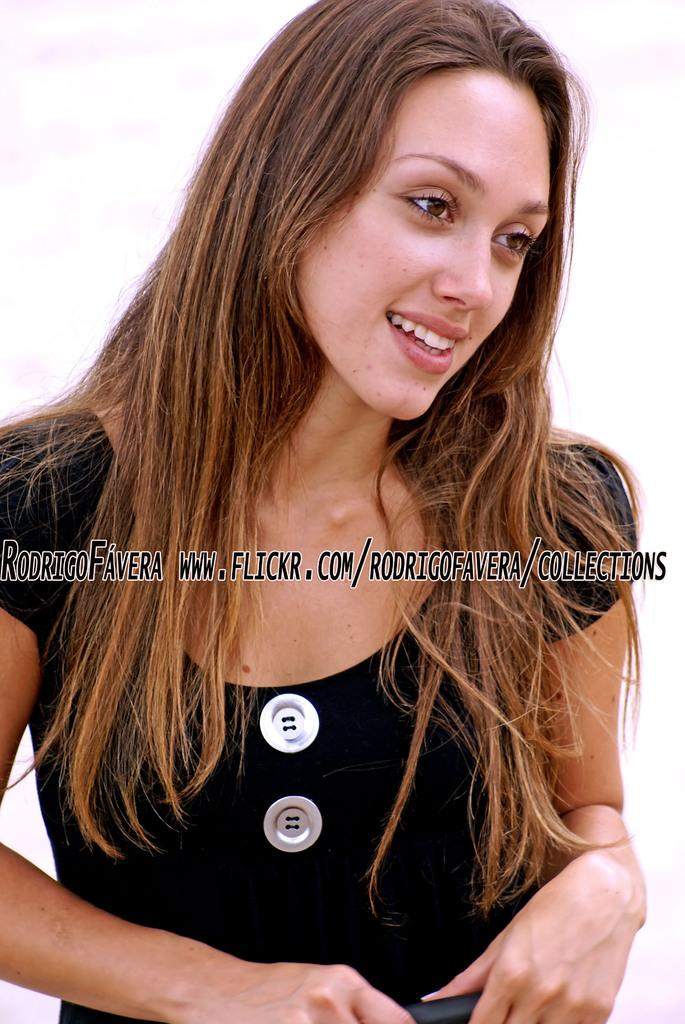What is the main subject of the image? The main subject of the image is a woman. What is the woman wearing in the image? The woman is wearing a black dress in the image. Can you describe the woman's hair in the image? The woman has loose brown hair in the image. What expression does the woman have in the image? The woman is smiling in the image. What type of doll is sitting on the brick in the image? There is no doll or brick present in the image. Is the woman in the image reading a fiction book? There is no book or indication of reading in the image. 